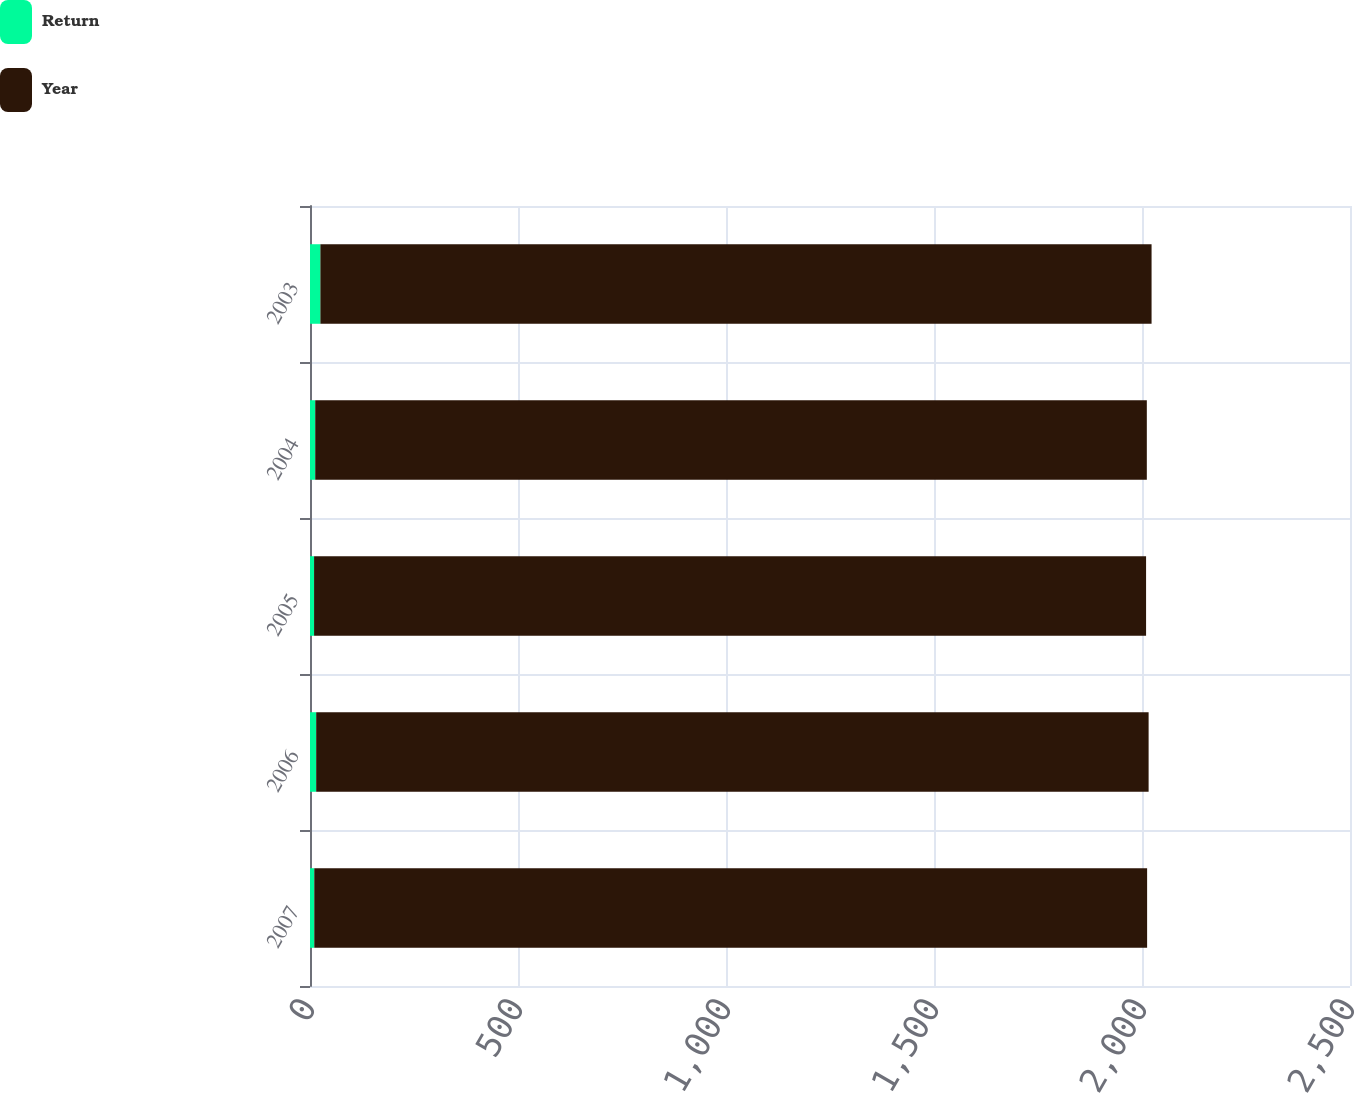<chart> <loc_0><loc_0><loc_500><loc_500><stacked_bar_chart><ecel><fcel>2007<fcel>2006<fcel>2005<fcel>2004<fcel>2003<nl><fcel>Return<fcel>10.3<fcel>14.9<fcel>9.8<fcel>12.6<fcel>25<nl><fcel>Year<fcel>2002<fcel>2001<fcel>2000<fcel>1999<fcel>1998<nl></chart> 